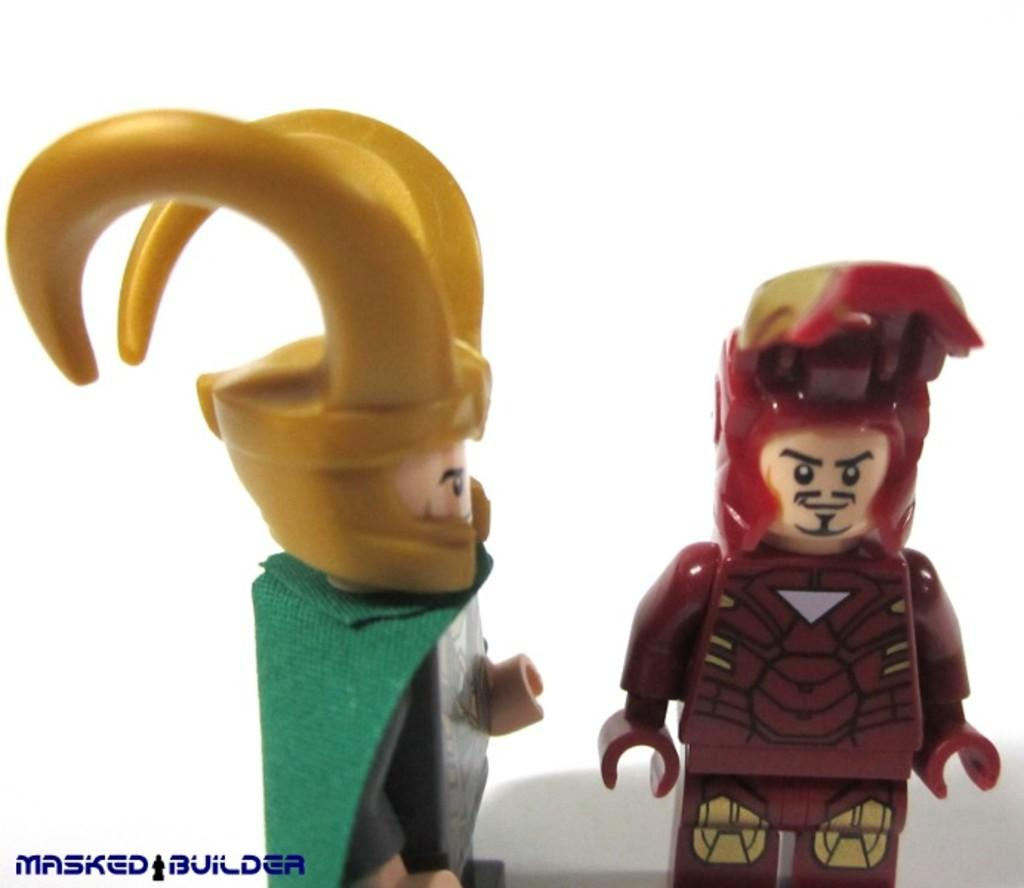How many toys are present in the image? There are two toys in the image. What is the color of the horns on one of the toys? The horns on one of the toys are yellow in color. What is the color of the other toy? The other toy is red in color. What type of market can be seen in the background of the image? There is no market visible in the image; it only features two toys. 